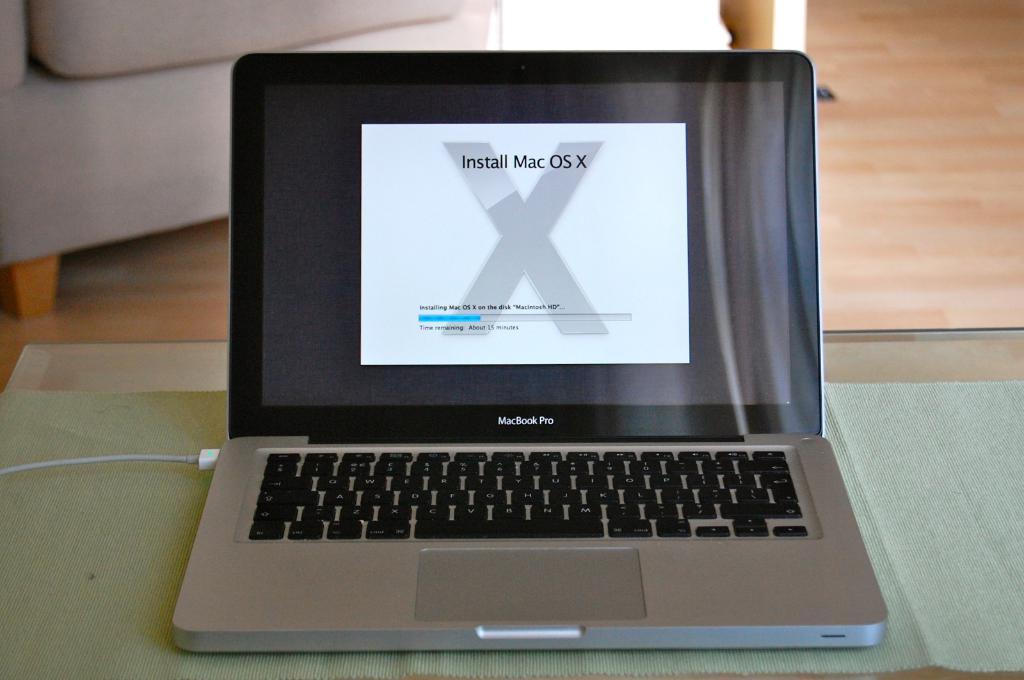What brand for operating system is being installed?
Provide a succinct answer. Mac os x. What is the model of the laptop?
Offer a terse response. Macbook pro. 